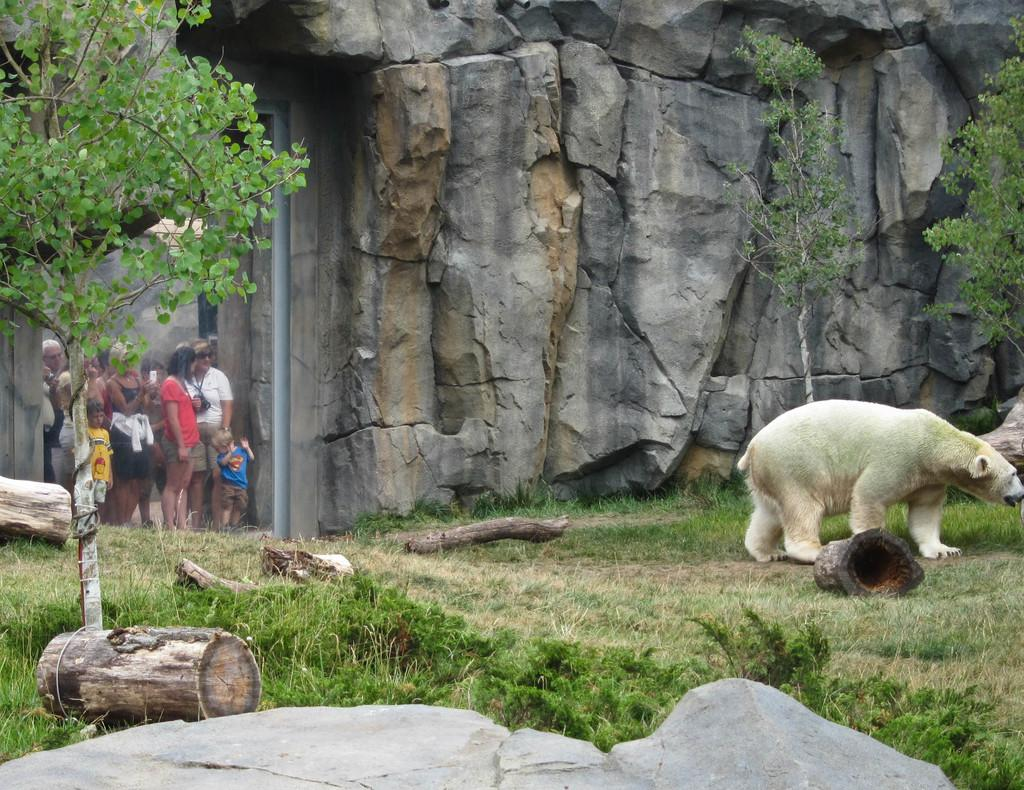What animal is the main subject of the image? There is a polar bear in the image. What type of material is present in the image? There are wooden logs in the image. What type of vegetation can be seen in the image? There are trees on the grass in the image. What can be seen in the background of the image? There is a group of people and rocks in the background of the image. What type of nose does the polar bear have in the image? The image does not show the polar bear's nose in detail, so it cannot be determined from the image. What type of lunch is being served to the group of people in the image? There is no indication of food or lunch being served in the image. 